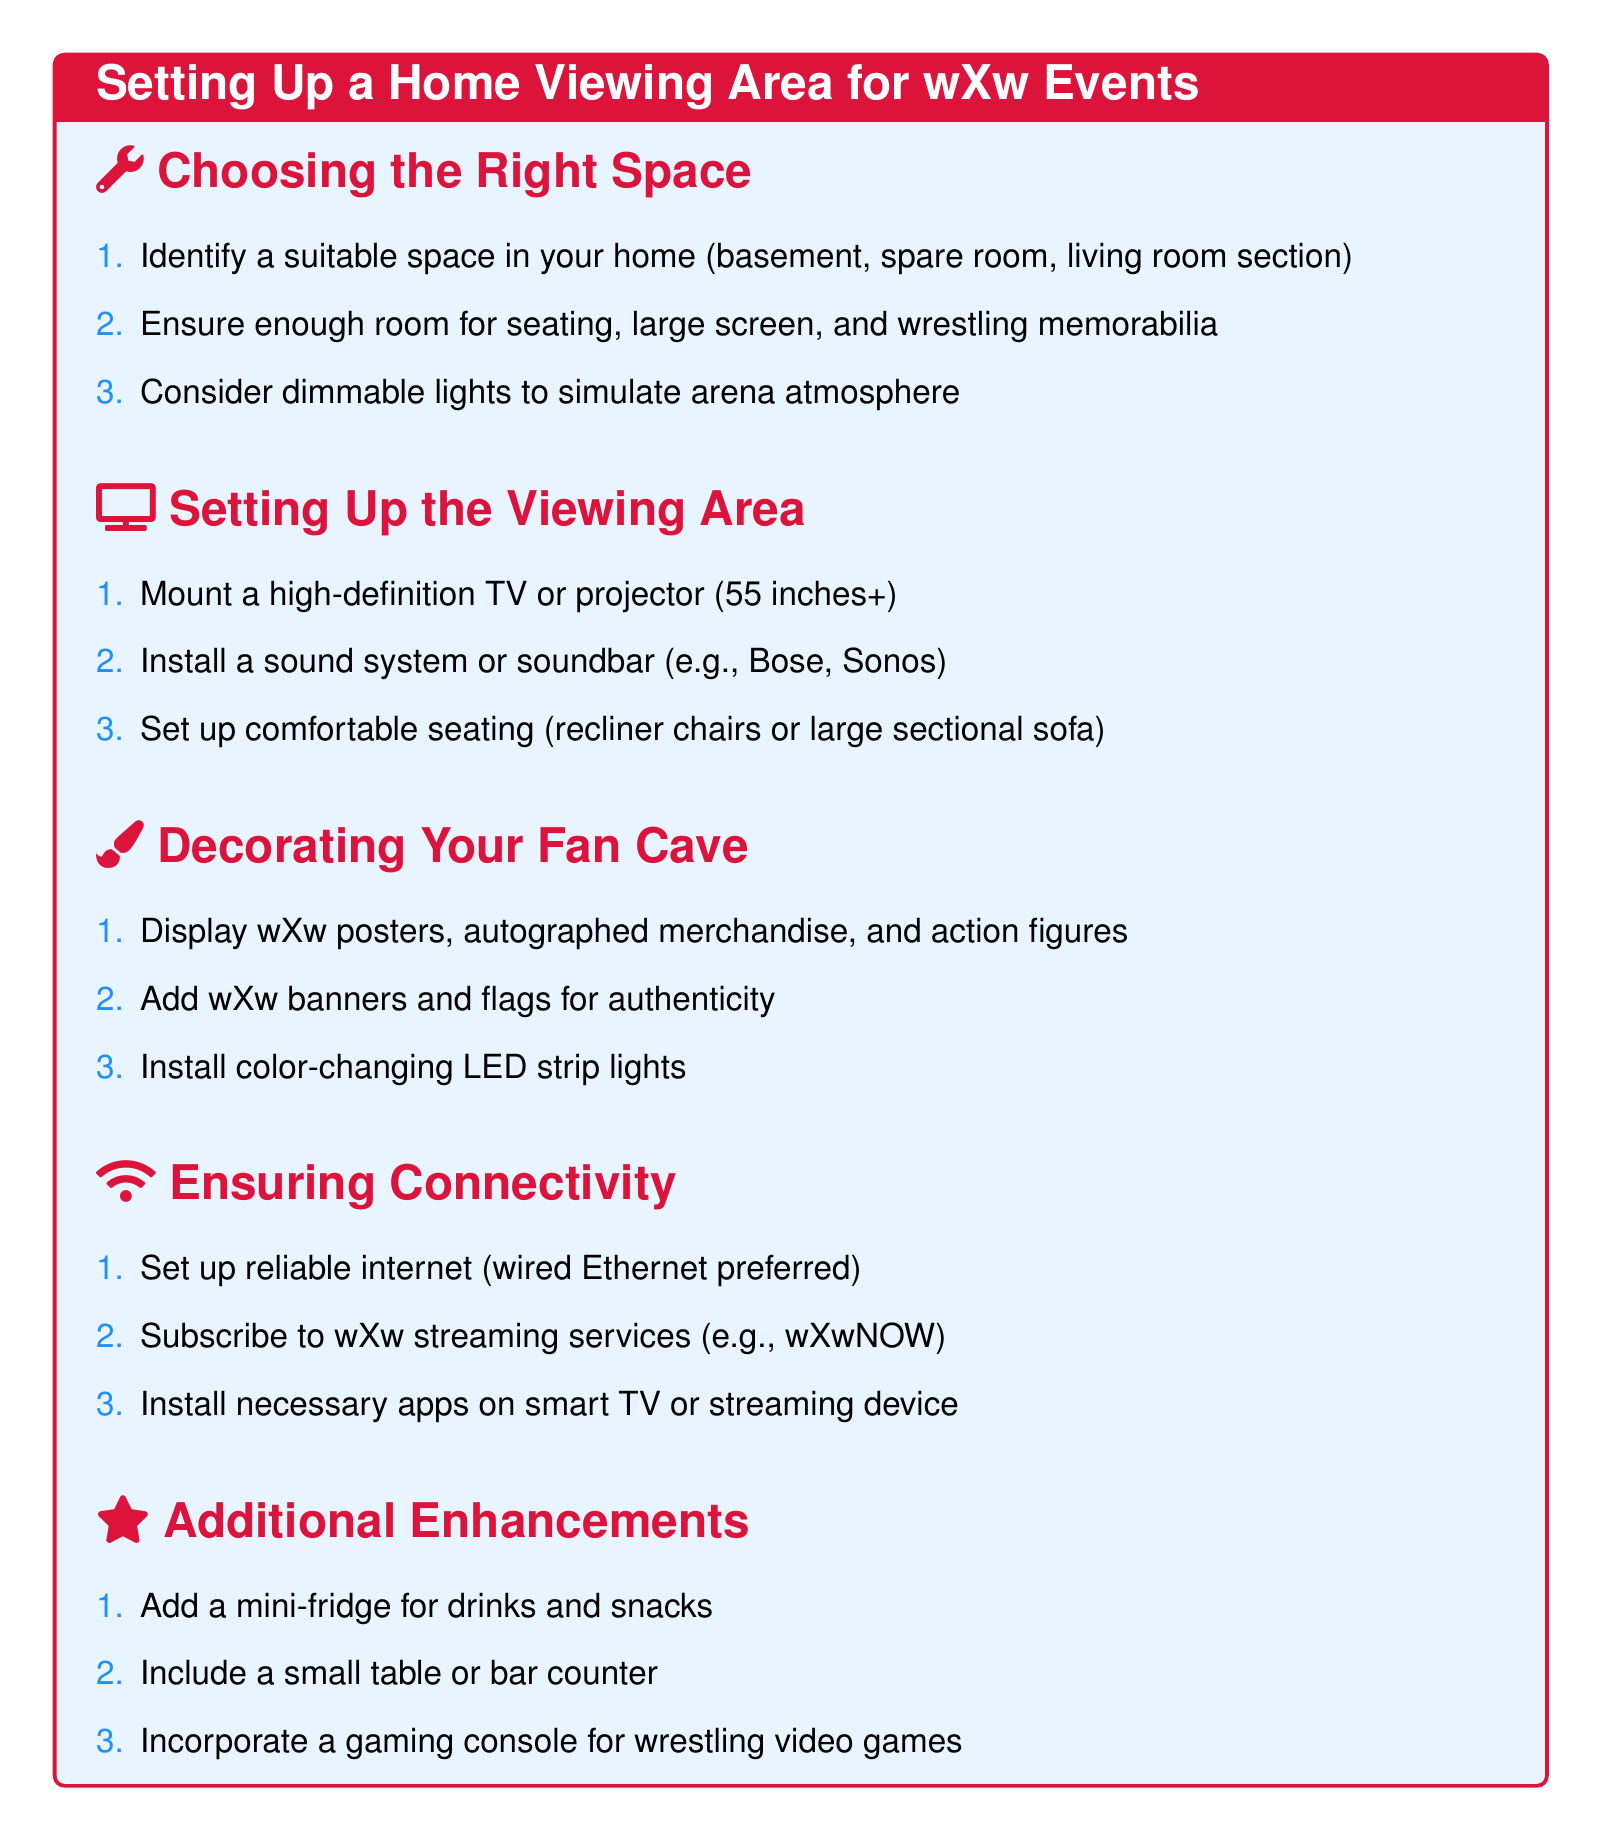what is the ideal size for the TV or projector? The document specifies that a high-definition TV or projector should be at least 55 inches.
Answer: 55 inches what type of lights should be used to enhance the atmosphere? The document suggests using dimmable lights to simulate an arena atmosphere.
Answer: Dimmable lights what kind of seating is recommended? The document recommends comfortable seating like recliner chairs or large sectional sofas.
Answer: Recliner chairs or large sectional sofa which room types are suggested for setting up the viewing area? The document mentions suitable spaces such as a basement, spare room, or living room section.
Answer: Basement, spare room, living room section what is the preferred internet connection type? The document advises setting up a reliable internet connection, with wired Ethernet being preferred.
Answer: Wired Ethernet what is one suggested decoration for the fan cave? The document lists displaying wXw posters, autographed merchandise, and action figures as a decoration option.
Answer: wXw posters how can fans enhance their viewing experience with snacks? The document suggests adding a mini-fridge for drinks and snacks.
Answer: Mini-fridge which type of system is recommended for sound? The document recommends installing a sound system or soundbar such as Bose or Sonos.
Answer: Sound system or soundbar what streaming service should fans subscribe to? The document mentions that fans should subscribe to wXw streaming services, specifically wXwNOW.
Answer: wXwNOW 